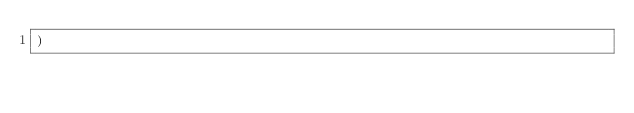Convert code to text. <code><loc_0><loc_0><loc_500><loc_500><_SQL_>)</code> 